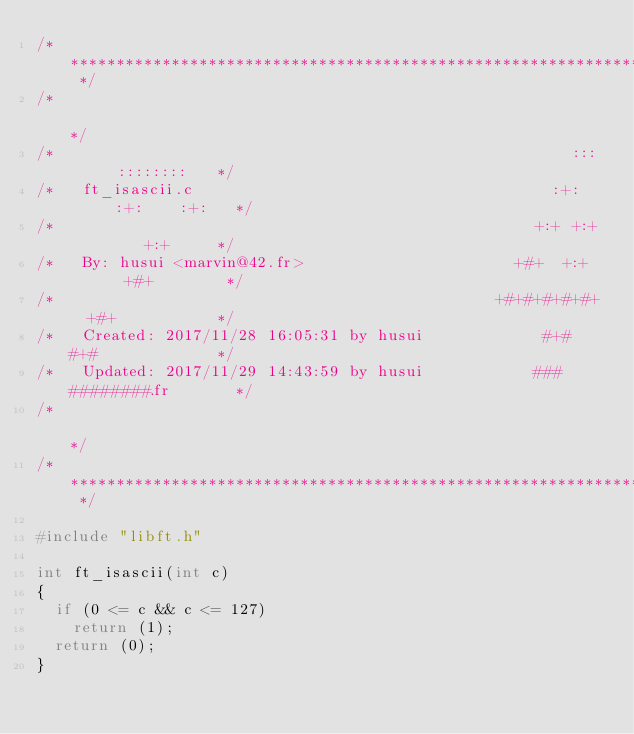<code> <loc_0><loc_0><loc_500><loc_500><_C_>/* ************************************************************************** */
/*                                                                            */
/*                                                        :::      ::::::::   */
/*   ft_isascii.c                                       :+:      :+:    :+:   */
/*                                                    +:+ +:+         +:+     */
/*   By: husui <marvin@42.fr>                       +#+  +:+       +#+        */
/*                                                +#+#+#+#+#+   +#+           */
/*   Created: 2017/11/28 16:05:31 by husui             #+#    #+#             */
/*   Updated: 2017/11/29 14:43:59 by husui            ###   ########.fr       */
/*                                                                            */
/* ************************************************************************** */

#include "libft.h"

int	ft_isascii(int c)
{
	if (0 <= c && c <= 127)
		return (1);
	return (0);
}
</code> 